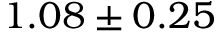<formula> <loc_0><loc_0><loc_500><loc_500>1 . 0 8 \pm 0 . 2 5</formula> 